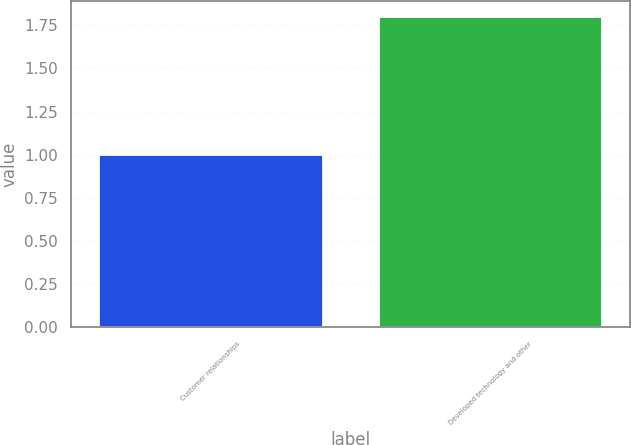<chart> <loc_0><loc_0><loc_500><loc_500><bar_chart><fcel>Customer relationships<fcel>Developed technology and other<nl><fcel>1<fcel>1.8<nl></chart> 